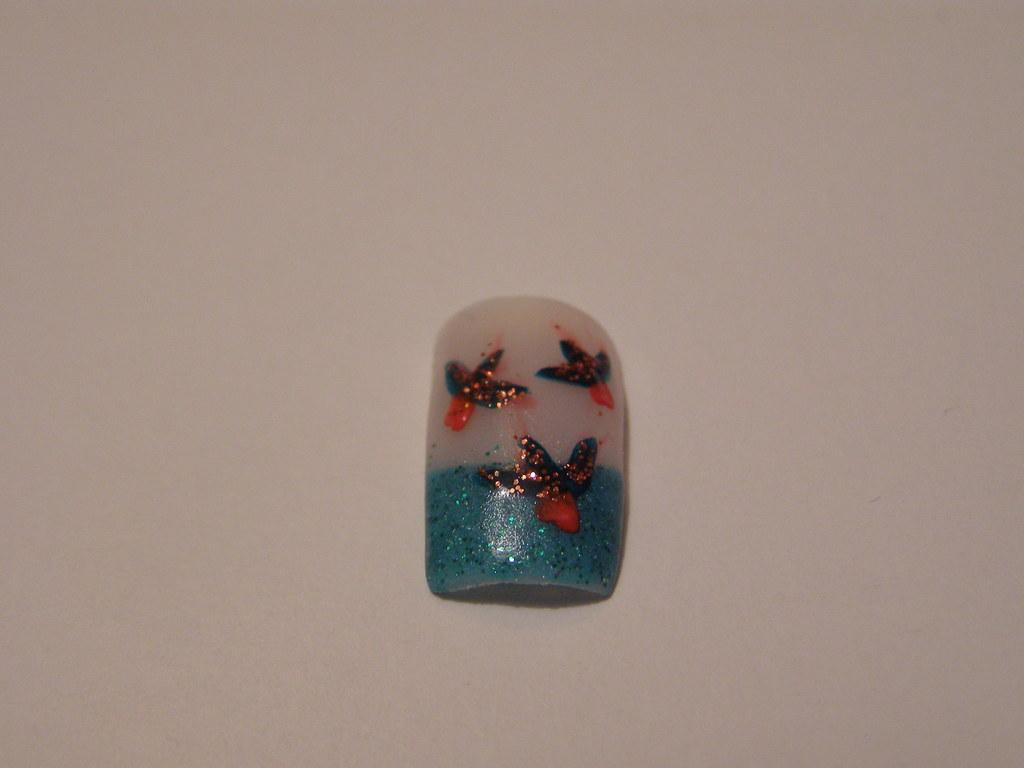What object can be seen in the image? There is a nail in the image. What is unique about the appearance of the nail? The nail has some painting on it. Where is the nail located in the image? The nail is kept on the floor. How many dolls are sitting on the sheet in the image? There is no sheet or dolls present in the image; it only features a painted nail on the floor. 